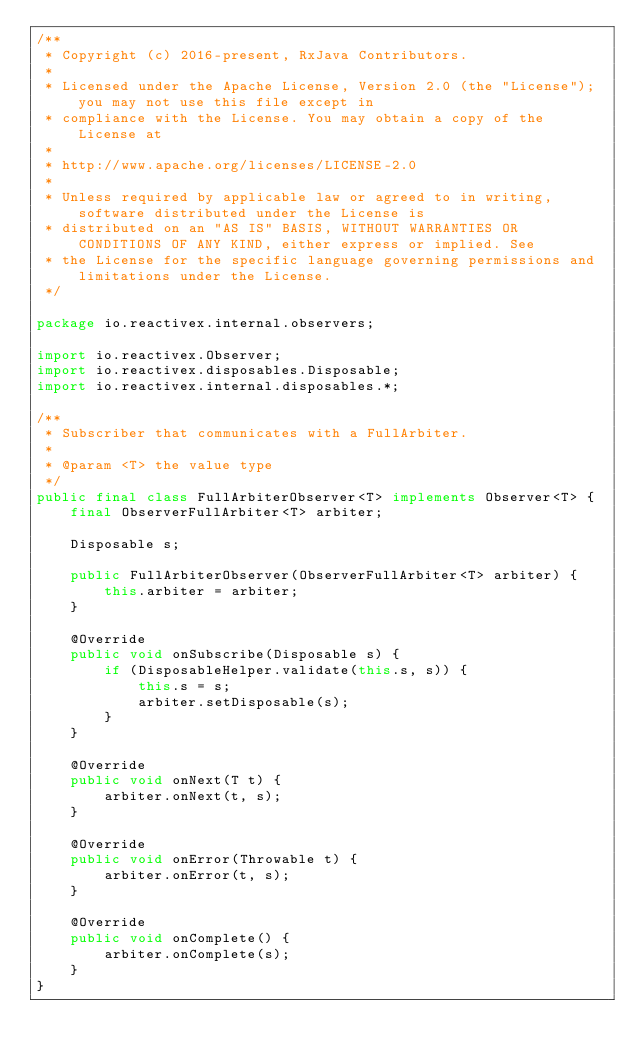Convert code to text. <code><loc_0><loc_0><loc_500><loc_500><_Java_>/**
 * Copyright (c) 2016-present, RxJava Contributors.
 *
 * Licensed under the Apache License, Version 2.0 (the "License"); you may not use this file except in
 * compliance with the License. You may obtain a copy of the License at
 *
 * http://www.apache.org/licenses/LICENSE-2.0
 *
 * Unless required by applicable law or agreed to in writing, software distributed under the License is
 * distributed on an "AS IS" BASIS, WITHOUT WARRANTIES OR CONDITIONS OF ANY KIND, either express or implied. See
 * the License for the specific language governing permissions and limitations under the License.
 */

package io.reactivex.internal.observers;

import io.reactivex.Observer;
import io.reactivex.disposables.Disposable;
import io.reactivex.internal.disposables.*;

/**
 * Subscriber that communicates with a FullArbiter.
 *
 * @param <T> the value type
 */
public final class FullArbiterObserver<T> implements Observer<T> {
    final ObserverFullArbiter<T> arbiter;

    Disposable s;

    public FullArbiterObserver(ObserverFullArbiter<T> arbiter) {
        this.arbiter = arbiter;
    }

    @Override
    public void onSubscribe(Disposable s) {
        if (DisposableHelper.validate(this.s, s)) {
            this.s = s;
            arbiter.setDisposable(s);
        }
    }

    @Override
    public void onNext(T t) {
        arbiter.onNext(t, s);
    }

    @Override
    public void onError(Throwable t) {
        arbiter.onError(t, s);
    }

    @Override
    public void onComplete() {
        arbiter.onComplete(s);
    }
}
</code> 